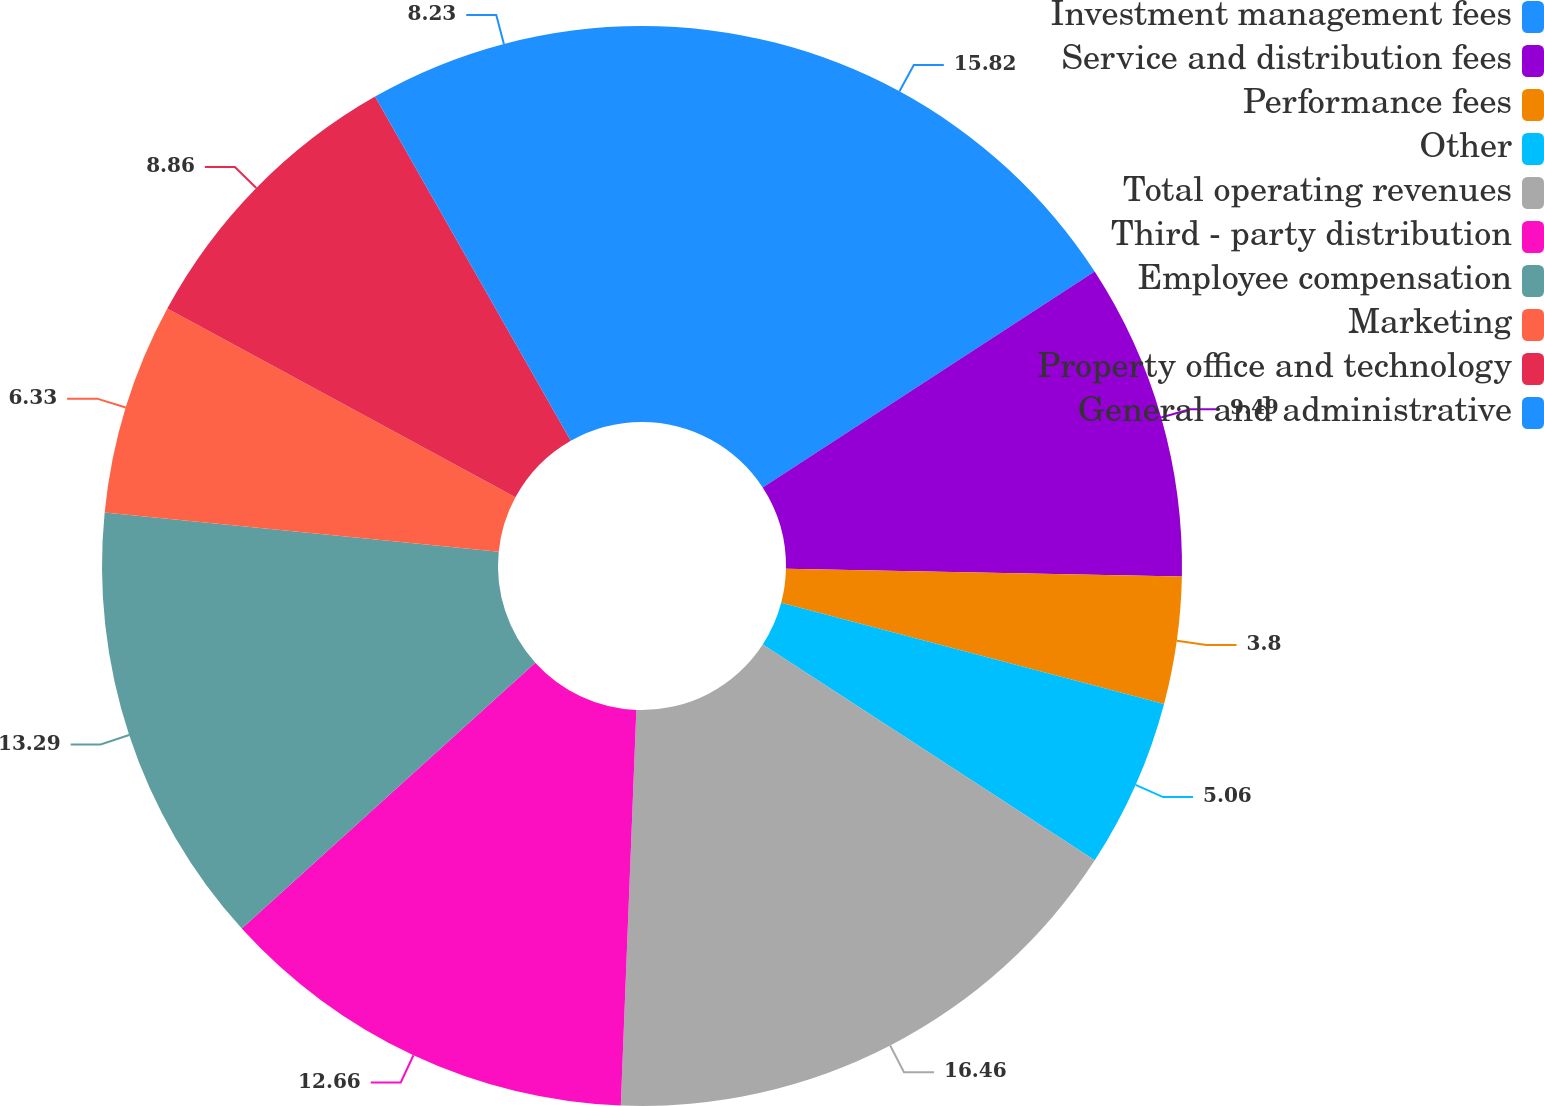Convert chart to OTSL. <chart><loc_0><loc_0><loc_500><loc_500><pie_chart><fcel>Investment management fees<fcel>Service and distribution fees<fcel>Performance fees<fcel>Other<fcel>Total operating revenues<fcel>Third - party distribution<fcel>Employee compensation<fcel>Marketing<fcel>Property office and technology<fcel>General and administrative<nl><fcel>15.82%<fcel>9.49%<fcel>3.8%<fcel>5.06%<fcel>16.45%<fcel>12.66%<fcel>13.29%<fcel>6.33%<fcel>8.86%<fcel>8.23%<nl></chart> 